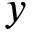<formula> <loc_0><loc_0><loc_500><loc_500>y</formula> 